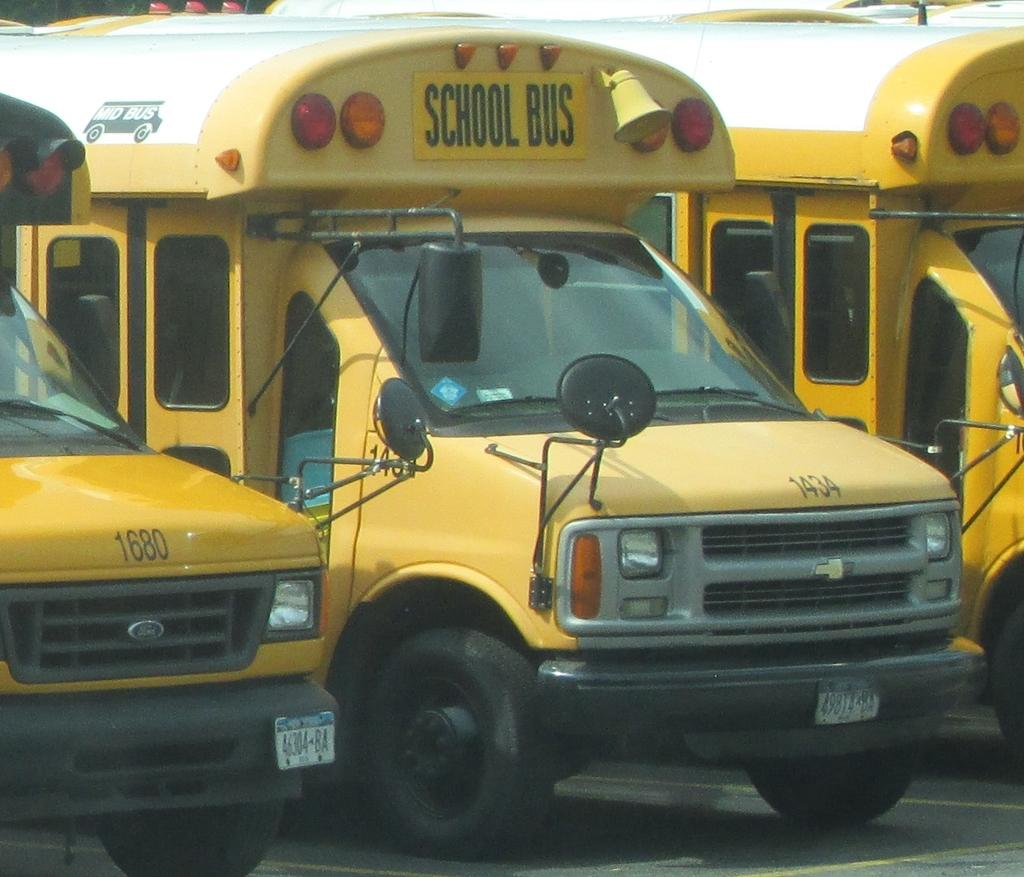What is the main subject of the image? The main subject of the image is three school buses. Where are the buses located in the image? The buses are parked in a parking zone. Can you tell me how many lizards are crawling on the buses in the image? There are no lizards present in the image; it only features three school buses parked in a parking zone. What type of tray is visible on the buses in the image? There is no tray visible on the buses in the image. 